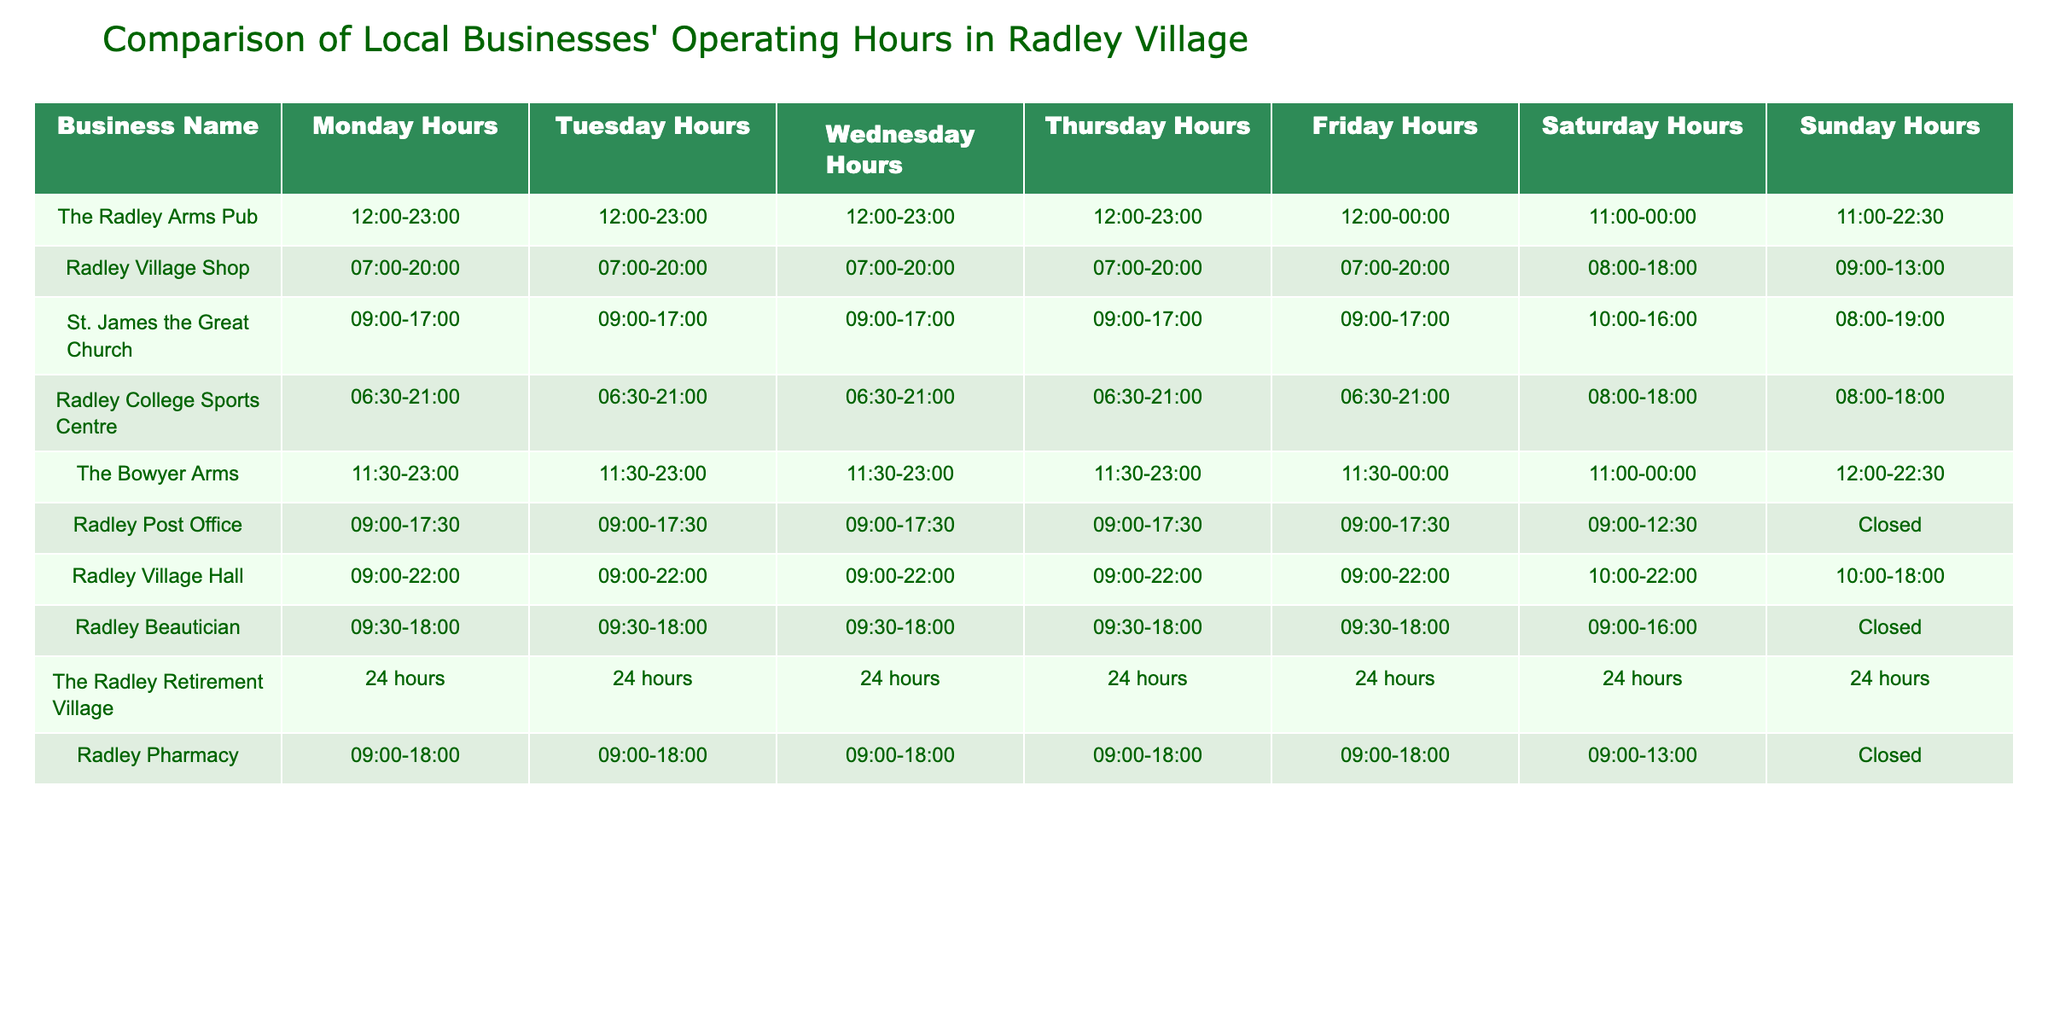What are the operating hours of The Radley Arms Pub on Fridays? The table shows that The Radley Arms Pub operates from 12:00 to 00:00 on Fridays.
Answer: 12:00-00:00 How many hours does Radley Village Shop operate on Saturdays? On Saturdays, Radley Village Shop operates for 10 hours, from 08:00 to 18:00.
Answer: 10 hours Is Radley Post Office open on Sundays? Based on the table, Radley Post Office is marked as closed on Sundays.
Answer: No Which business has the longest operating hours on Thursdays? By comparing the hours, The Radley Retirement Village operates 24 hours on Thursdays, which is longer than any other business.
Answer: The Radley Retirement Village On which day does Radley Pharmacy close? The table indicates that Radley Pharmacy is closed on Sundays.
Answer: Sundays What is the difference in closing times between The Bowyer Arms and Radley Village Hall on Saturdays? The Bowyer Arms closes at 00:00, while Radley Village Hall closes at 22:00. The difference in closing times is 2 hours (00:00 - 22:00).
Answer: 2 hours Which business operates the same hours every day? The Radley Retirement Village operates the same hours (24 hours) every day of the week.
Answer: The Radley Retirement Village How many businesses are open after 22:00 on Fridays? On Fridays, The Radley Arms Pub and The Bowyer Arms are open, as they close at 00:00. Therefore, there are 2 businesses open after 22:00.
Answer: 2 businesses What are the evening closing hours for St. James the Great Church on Wednesdays? St. James the Great Church closes at 17:00 on Wednesdays, according to the table.
Answer: 17:00 Which business has the latest closing time on Sundays? The Radley Arms Pub has the latest closing time on Sundays at 22:30.
Answer: The Radley Arms Pub How many hours does Radley Village Hall operate on Mondays? Radley Village Hall operates for 13 hours on Mondays, from 09:00 to 22:00.
Answer: 13 hours 